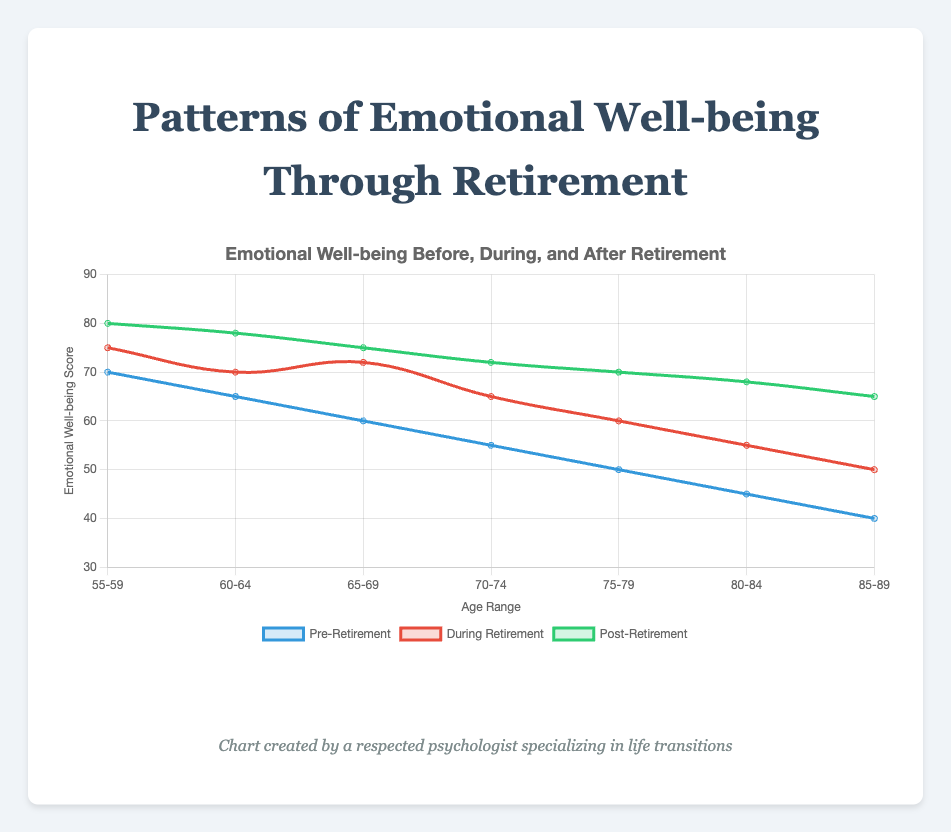Which age range shows the highest increase in emotional well-being from pre-retirement to post-retirement? To determine which age range shows the highest increase, we look at the difference between the post-retirement and pre-retirement scores for each age range. The highest increase is seen in the 55-59 age range with an increase of 10 (80 - 70 = 10).
Answer: 55-59 In the 60-64 age range, which retirement phase has the greatest emotional well-being score? We compare the scores in the 60-64 age range across the three phases: pre-retirement (65), during retirement (70), and post-retirement (78). The post-retirement phase has the highest score of 78.
Answer: Post-retirement Which colored line represents the emotional well-being during retirement? Based on the figure's legend, the line representing emotional well-being during retirement is the red line.
Answer: Red What is the overall trend in emotional well-being scores from pre-retirement to post-retirement across all age ranges? By observing the lines on the graph, we notice that emotional well-being scores generally increase from pre-retirement to post-retirement across all age ranges. The pre-retirement scores are the lowest, and post-retirement scores are the highest consistently.
Answer: Increase Calculate the average emotional well-being score for the 75-79 age range across all three retirement phases. To find the average, we sum the scores for pre-retirement (50), during retirement (60), and post-retirement (70) and then divide by 3. (50 + 60 + 70) / 3 = 180 / 3 = 60.
Answer: 60 In which age range does the emotional well-being during retirement exceed the pre-retirement score by exactly ten points? We identify the age range where the difference between the during-retirement and pre-retirement scores is 10. For 65-69, the scores are 72 (during) and 60 (pre), resulting in a difference of 12 (not 10). For 70-74, the scores are 65 (during) and 55 (pre), resulting in a difference of exactly 10.
Answer: 70-74 